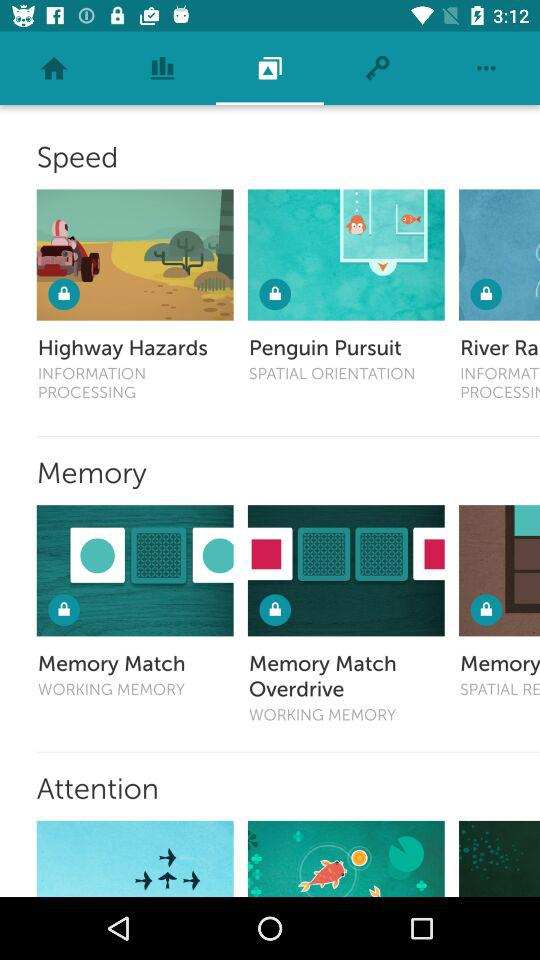What are the locked "WORKING MEMORY"? The locked "WORKING MEMORY" are "Memory Match" and "Memory Match Overdrive". 